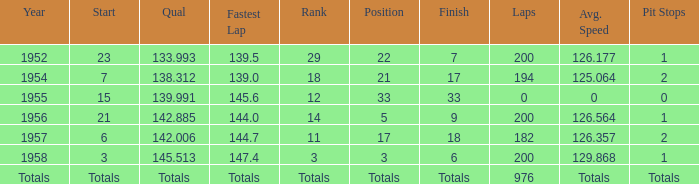What place did Jimmy Reece finish in 1957? 18.0. 